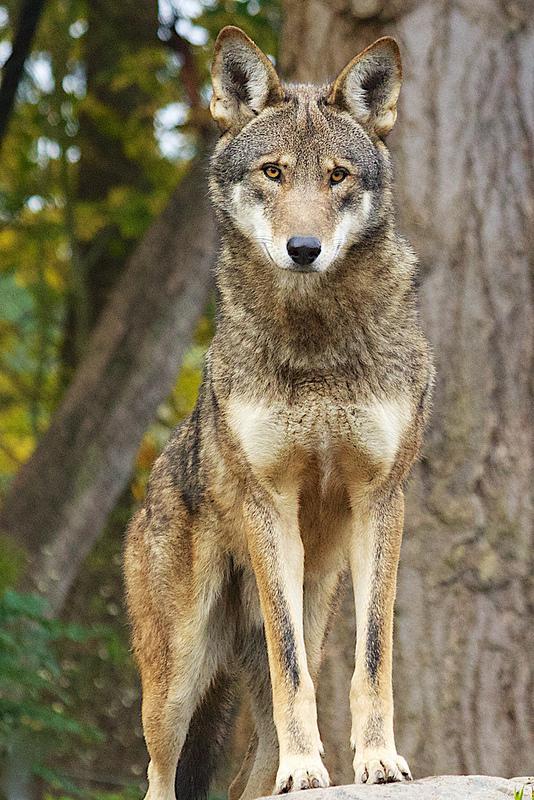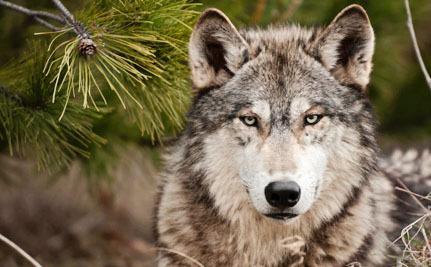The first image is the image on the left, the second image is the image on the right. Analyze the images presented: Is the assertion "Three wolves are visible." valid? Answer yes or no. No. The first image is the image on the left, the second image is the image on the right. Assess this claim about the two images: "The left image contains twice as many wolves as the right image.". Correct or not? Answer yes or no. No. 